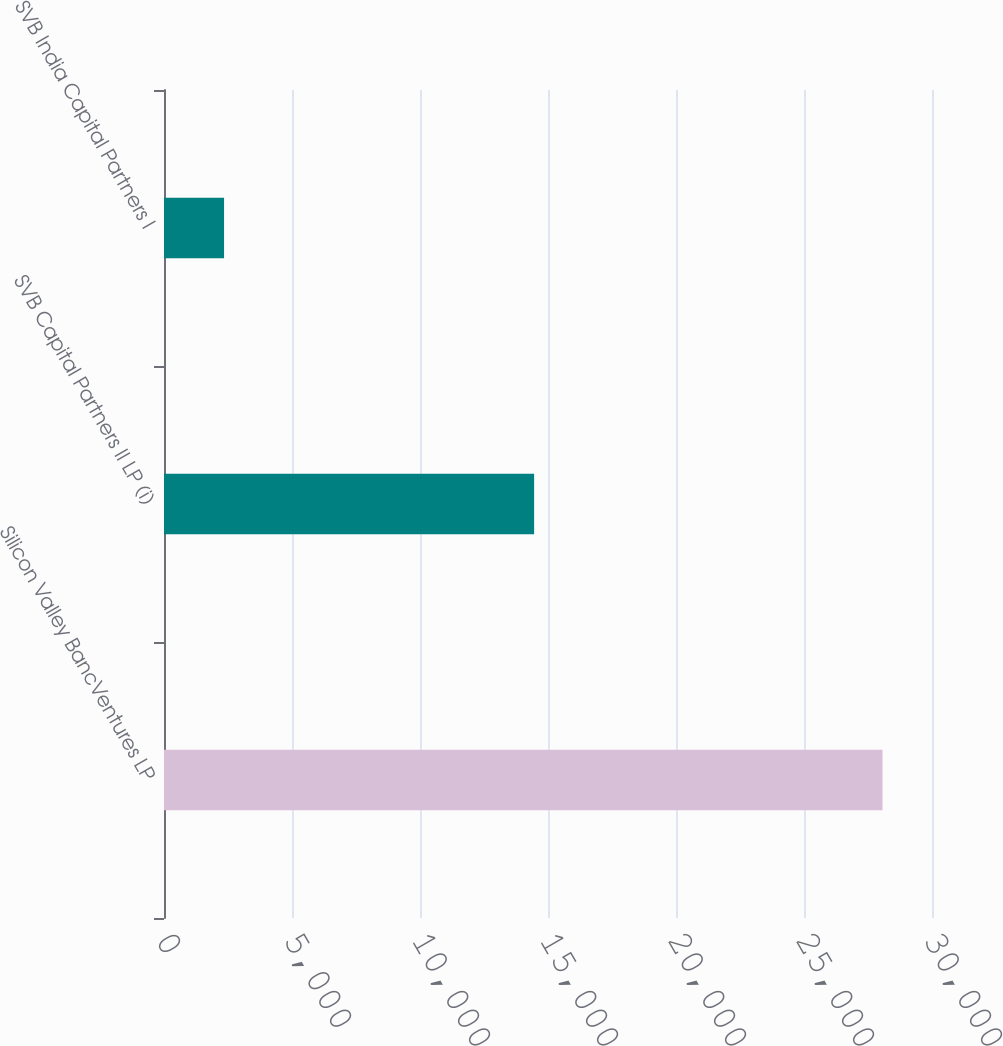<chart> <loc_0><loc_0><loc_500><loc_500><bar_chart><fcel>Silicon Valley BancVentures LP<fcel>SVB Capital Partners II LP (i)<fcel>SVB India Capital Partners I<nl><fcel>28068<fcel>14458<fcel>2346<nl></chart> 